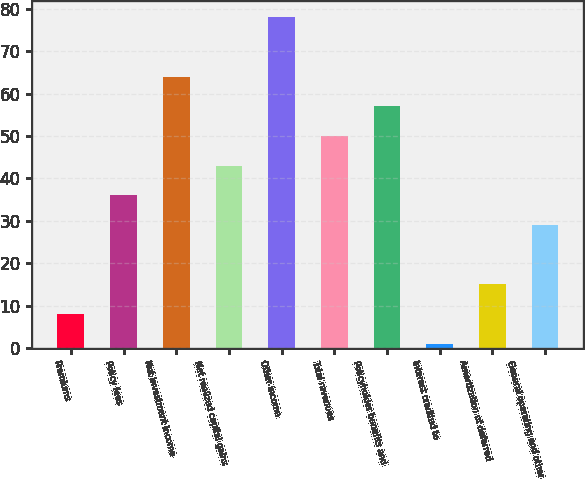Convert chart to OTSL. <chart><loc_0><loc_0><loc_500><loc_500><bar_chart><fcel>Premiums<fcel>Policy fees<fcel>Net investment income<fcel>Net realized capital gains<fcel>Other income<fcel>Total revenues<fcel>Policyholder benefits and<fcel>Interest credited to<fcel>Amortization of deferred<fcel>General operating and other<nl><fcel>8<fcel>36<fcel>64<fcel>43<fcel>78<fcel>50<fcel>57<fcel>1<fcel>15<fcel>29<nl></chart> 